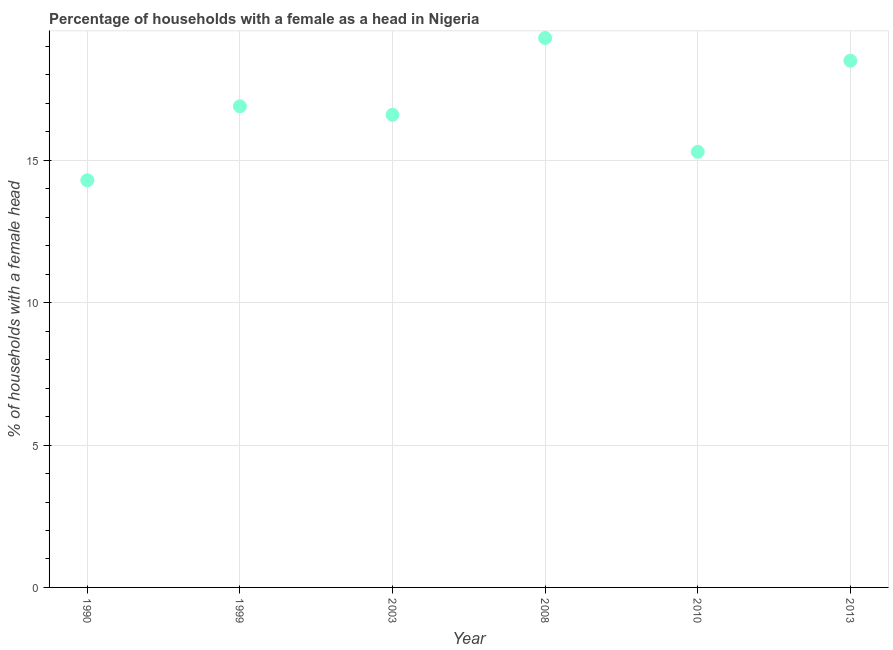Across all years, what is the maximum number of female supervised households?
Your answer should be very brief. 19.3. Across all years, what is the minimum number of female supervised households?
Give a very brief answer. 14.3. In which year was the number of female supervised households maximum?
Ensure brevity in your answer.  2008. In which year was the number of female supervised households minimum?
Provide a succinct answer. 1990. What is the sum of the number of female supervised households?
Your response must be concise. 100.9. What is the difference between the number of female supervised households in 1999 and 2003?
Your answer should be very brief. 0.3. What is the average number of female supervised households per year?
Your response must be concise. 16.82. What is the median number of female supervised households?
Ensure brevity in your answer.  16.75. In how many years, is the number of female supervised households greater than 14 %?
Make the answer very short. 6. Do a majority of the years between 1999 and 2003 (inclusive) have number of female supervised households greater than 7 %?
Your answer should be very brief. Yes. What is the ratio of the number of female supervised households in 1990 to that in 2003?
Make the answer very short. 0.86. What is the difference between the highest and the second highest number of female supervised households?
Keep it short and to the point. 0.8. Is the sum of the number of female supervised households in 2008 and 2010 greater than the maximum number of female supervised households across all years?
Your answer should be compact. Yes. What is the difference between the highest and the lowest number of female supervised households?
Make the answer very short. 5. In how many years, is the number of female supervised households greater than the average number of female supervised households taken over all years?
Your answer should be very brief. 3. Does the number of female supervised households monotonically increase over the years?
Ensure brevity in your answer.  No. How many dotlines are there?
Ensure brevity in your answer.  1. How many years are there in the graph?
Provide a succinct answer. 6. What is the difference between two consecutive major ticks on the Y-axis?
Offer a very short reply. 5. What is the title of the graph?
Provide a succinct answer. Percentage of households with a female as a head in Nigeria. What is the label or title of the X-axis?
Give a very brief answer. Year. What is the label or title of the Y-axis?
Ensure brevity in your answer.  % of households with a female head. What is the % of households with a female head in 1990?
Ensure brevity in your answer.  14.3. What is the % of households with a female head in 1999?
Offer a terse response. 16.9. What is the % of households with a female head in 2008?
Offer a very short reply. 19.3. What is the difference between the % of households with a female head in 1990 and 1999?
Keep it short and to the point. -2.6. What is the difference between the % of households with a female head in 1990 and 2003?
Your response must be concise. -2.3. What is the difference between the % of households with a female head in 1990 and 2013?
Offer a terse response. -4.2. What is the difference between the % of households with a female head in 1999 and 2003?
Offer a very short reply. 0.3. What is the difference between the % of households with a female head in 1999 and 2010?
Keep it short and to the point. 1.6. What is the difference between the % of households with a female head in 1999 and 2013?
Your answer should be compact. -1.6. What is the difference between the % of households with a female head in 2003 and 2013?
Give a very brief answer. -1.9. What is the difference between the % of households with a female head in 2008 and 2010?
Keep it short and to the point. 4. What is the ratio of the % of households with a female head in 1990 to that in 1999?
Your answer should be compact. 0.85. What is the ratio of the % of households with a female head in 1990 to that in 2003?
Give a very brief answer. 0.86. What is the ratio of the % of households with a female head in 1990 to that in 2008?
Give a very brief answer. 0.74. What is the ratio of the % of households with a female head in 1990 to that in 2010?
Keep it short and to the point. 0.94. What is the ratio of the % of households with a female head in 1990 to that in 2013?
Offer a terse response. 0.77. What is the ratio of the % of households with a female head in 1999 to that in 2008?
Give a very brief answer. 0.88. What is the ratio of the % of households with a female head in 1999 to that in 2010?
Offer a terse response. 1.1. What is the ratio of the % of households with a female head in 1999 to that in 2013?
Provide a short and direct response. 0.91. What is the ratio of the % of households with a female head in 2003 to that in 2008?
Provide a short and direct response. 0.86. What is the ratio of the % of households with a female head in 2003 to that in 2010?
Provide a succinct answer. 1.08. What is the ratio of the % of households with a female head in 2003 to that in 2013?
Ensure brevity in your answer.  0.9. What is the ratio of the % of households with a female head in 2008 to that in 2010?
Provide a short and direct response. 1.26. What is the ratio of the % of households with a female head in 2008 to that in 2013?
Provide a succinct answer. 1.04. What is the ratio of the % of households with a female head in 2010 to that in 2013?
Give a very brief answer. 0.83. 